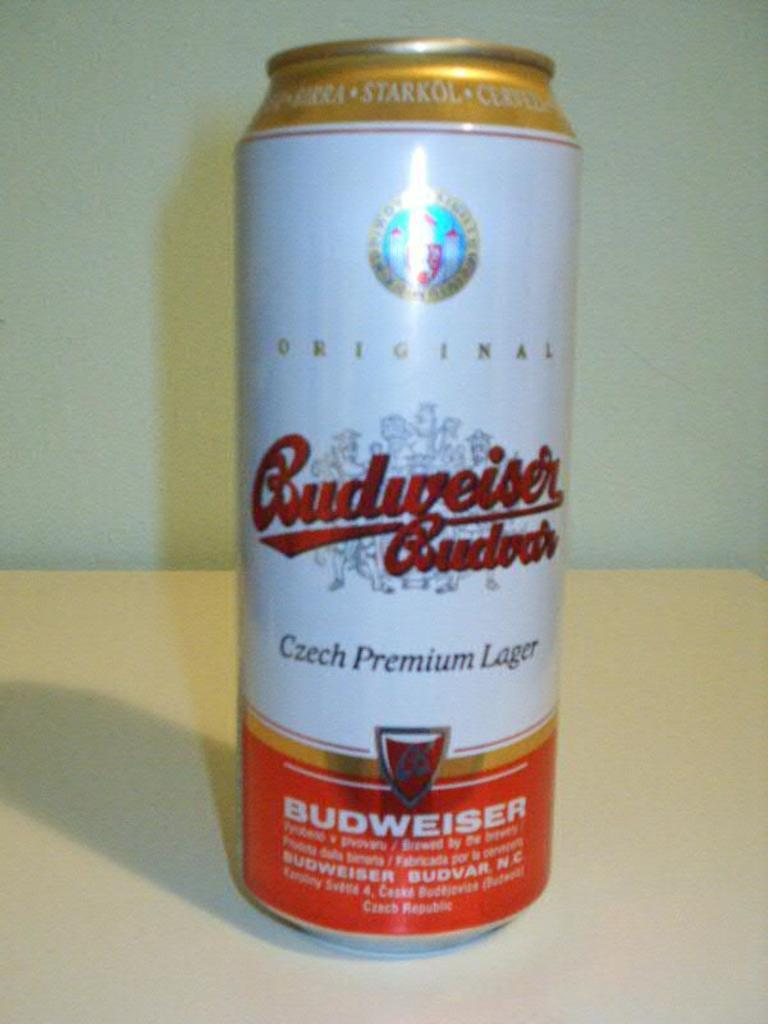<image>
Relay a brief, clear account of the picture shown. A can of Budweiser original czech premium lager 